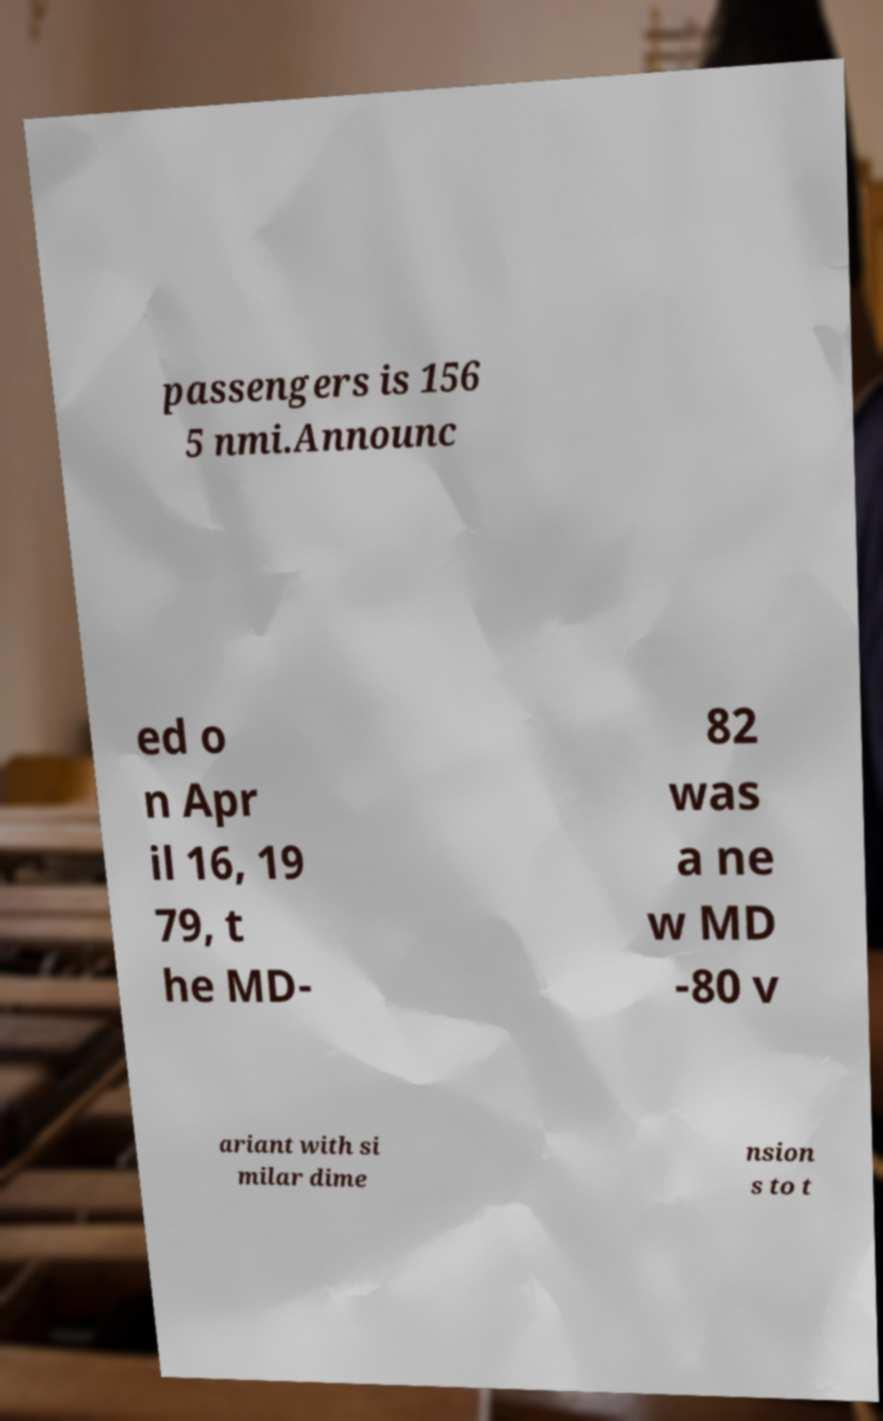Can you accurately transcribe the text from the provided image for me? passengers is 156 5 nmi.Announc ed o n Apr il 16, 19 79, t he MD- 82 was a ne w MD -80 v ariant with si milar dime nsion s to t 